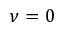Convert formula to latex. <formula><loc_0><loc_0><loc_500><loc_500>\nu = 0</formula> 